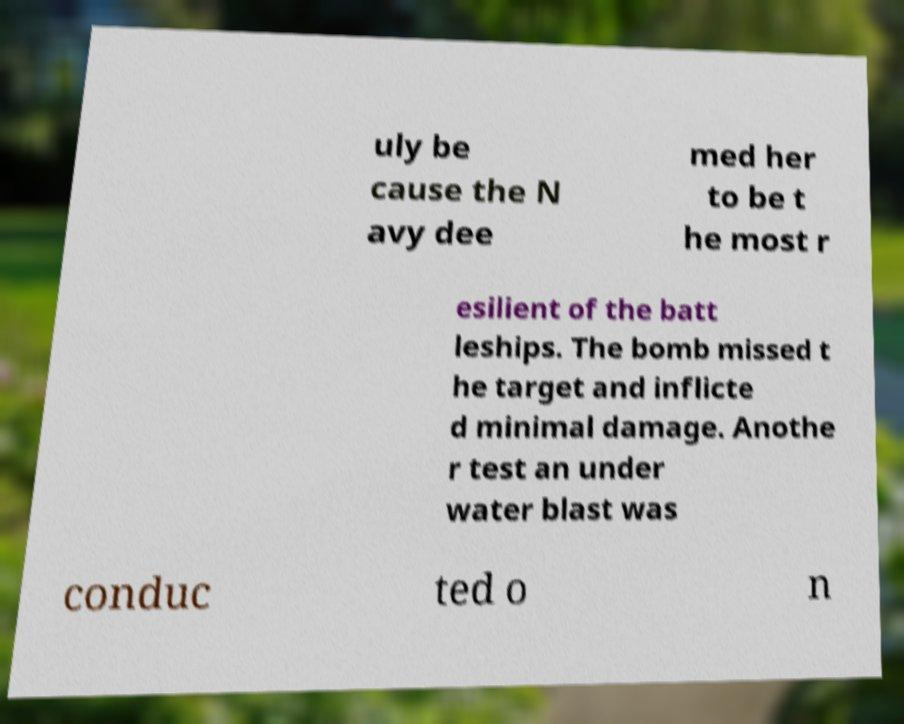Please identify and transcribe the text found in this image. uly be cause the N avy dee med her to be t he most r esilient of the batt leships. The bomb missed t he target and inflicte d minimal damage. Anothe r test an under water blast was conduc ted o n 